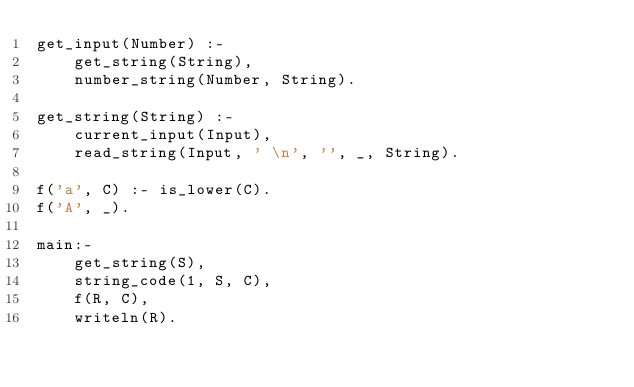Convert code to text. <code><loc_0><loc_0><loc_500><loc_500><_Prolog_>get_input(Number) :-
    get_string(String),
    number_string(Number, String).

get_string(String) :-
    current_input(Input),
    read_string(Input, ' \n', '', _, String).

f('a', C) :- is_lower(C).
f('A', _).

main:-
    get_string(S),
    string_code(1, S, C),
    f(R, C),
    writeln(R).
</code> 